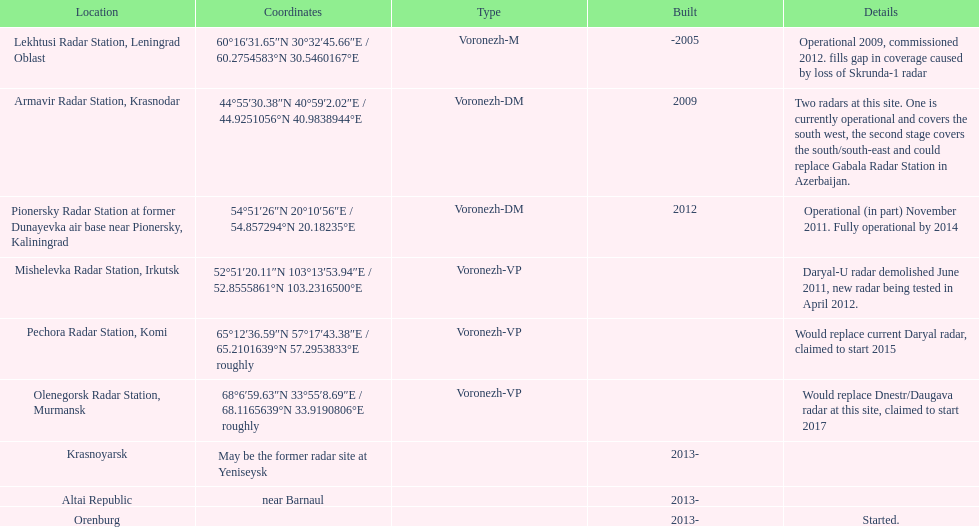Before the year 2010, what was the total count of voronezh radars that had been built? 2. 